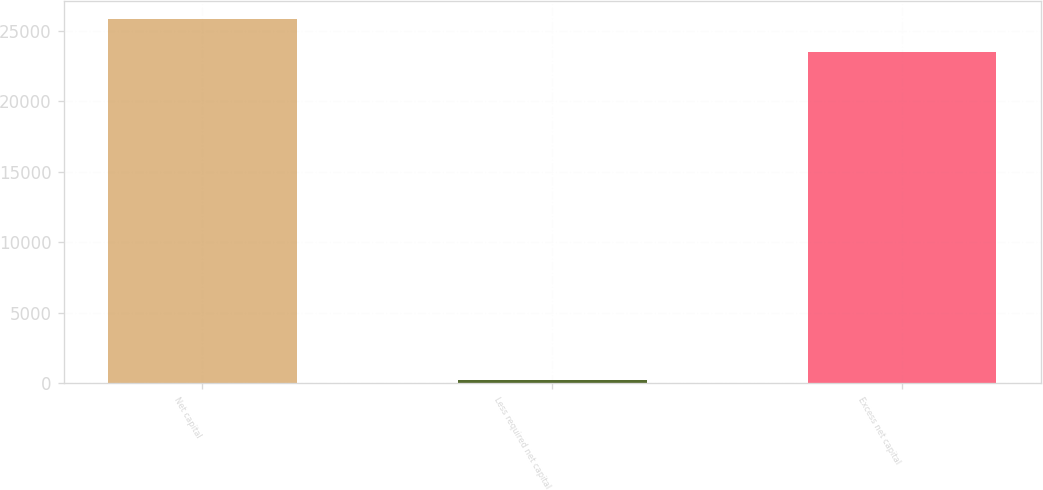Convert chart. <chart><loc_0><loc_0><loc_500><loc_500><bar_chart><fcel>Net capital<fcel>Less required net capital<fcel>Excess net capital<nl><fcel>25847.8<fcel>250<fcel>23498<nl></chart> 